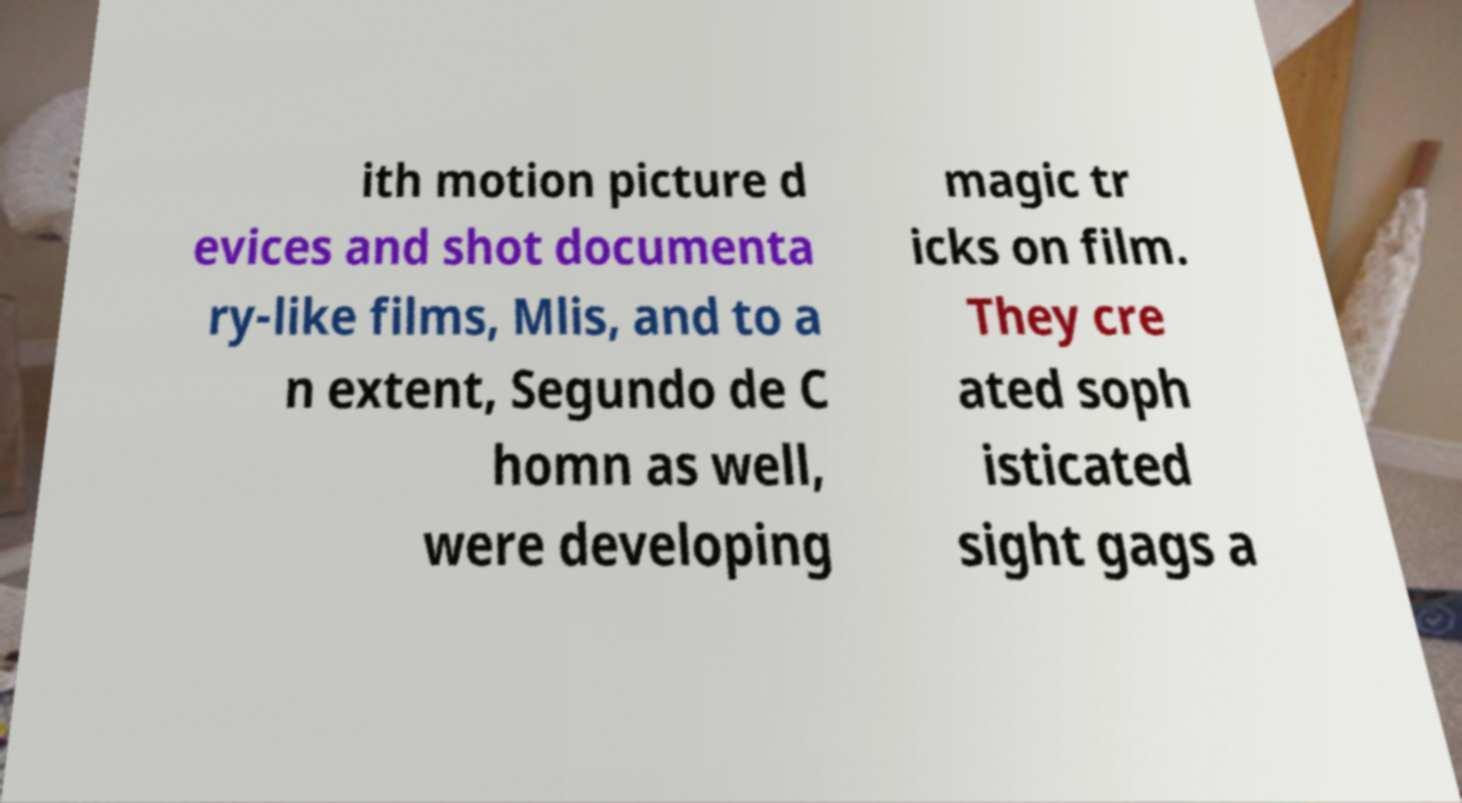Can you read and provide the text displayed in the image?This photo seems to have some interesting text. Can you extract and type it out for me? ith motion picture d evices and shot documenta ry-like films, Mlis, and to a n extent, Segundo de C homn as well, were developing magic tr icks on film. They cre ated soph isticated sight gags a 